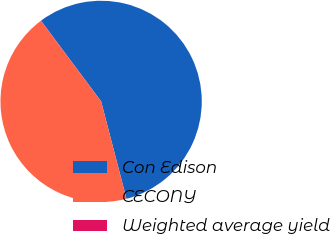<chart> <loc_0><loc_0><loc_500><loc_500><pie_chart><fcel>Con Edison<fcel>CECONY<fcel>Weighted average yield<nl><fcel>56.13%<fcel>43.84%<fcel>0.03%<nl></chart> 